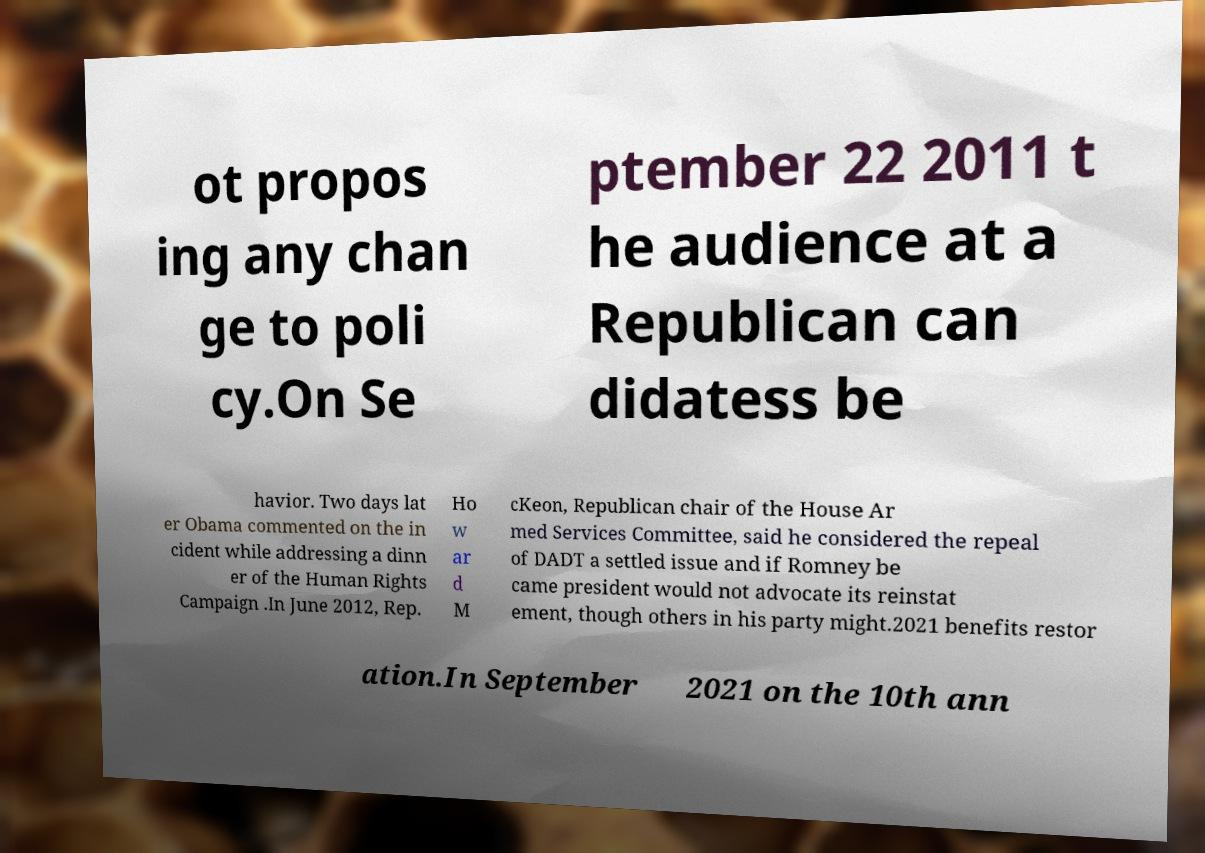What messages or text are displayed in this image? I need them in a readable, typed format. ot propos ing any chan ge to poli cy.On Se ptember 22 2011 t he audience at a Republican can didatess be havior. Two days lat er Obama commented on the in cident while addressing a dinn er of the Human Rights Campaign .In June 2012, Rep. Ho w ar d M cKeon, Republican chair of the House Ar med Services Committee, said he considered the repeal of DADT a settled issue and if Romney be came president would not advocate its reinstat ement, though others in his party might.2021 benefits restor ation.In September 2021 on the 10th ann 